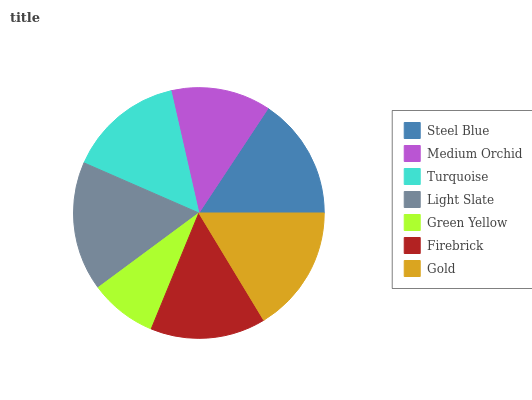Is Green Yellow the minimum?
Answer yes or no. Yes. Is Light Slate the maximum?
Answer yes or no. Yes. Is Medium Orchid the minimum?
Answer yes or no. No. Is Medium Orchid the maximum?
Answer yes or no. No. Is Steel Blue greater than Medium Orchid?
Answer yes or no. Yes. Is Medium Orchid less than Steel Blue?
Answer yes or no. Yes. Is Medium Orchid greater than Steel Blue?
Answer yes or no. No. Is Steel Blue less than Medium Orchid?
Answer yes or no. No. Is Turquoise the high median?
Answer yes or no. Yes. Is Turquoise the low median?
Answer yes or no. Yes. Is Medium Orchid the high median?
Answer yes or no. No. Is Steel Blue the low median?
Answer yes or no. No. 